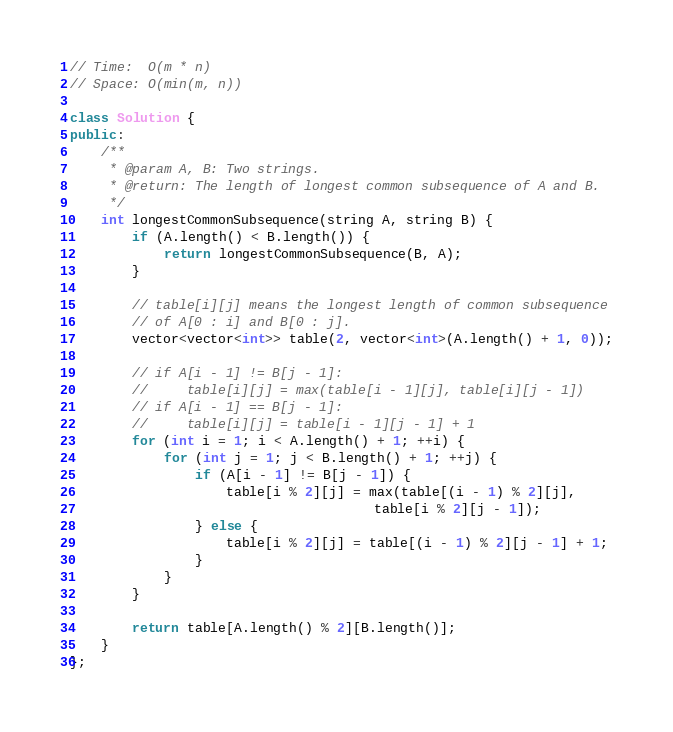Convert code to text. <code><loc_0><loc_0><loc_500><loc_500><_C++_>// Time:  O(m * n)
// Space: O(min(m, n))

class Solution {
public:
    /**
     * @param A, B: Two strings.
     * @return: The length of longest common subsequence of A and B.
     */
    int longestCommonSubsequence(string A, string B) {
        if (A.length() < B.length()) {
            return longestCommonSubsequence(B, A);
        }

        // table[i][j] means the longest length of common subsequence
        // of A[0 : i] and B[0 : j].
        vector<vector<int>> table(2, vector<int>(A.length() + 1, 0));

        // if A[i - 1] != B[j - 1]:
        //     table[i][j] = max(table[i - 1][j], table[i][j - 1])
        // if A[i - 1] == B[j - 1]:
        //     table[i][j] = table[i - 1][j - 1] + 1
        for (int i = 1; i < A.length() + 1; ++i) {
            for (int j = 1; j < B.length() + 1; ++j) {
                if (A[i - 1] != B[j - 1]) {
                    table[i % 2][j] = max(table[(i - 1) % 2][j],
                                       table[i % 2][j - 1]);
                } else {
                    table[i % 2][j] = table[(i - 1) % 2][j - 1] + 1;
                }
            }
        }

        return table[A.length() % 2][B.length()];
    }
};

</code> 